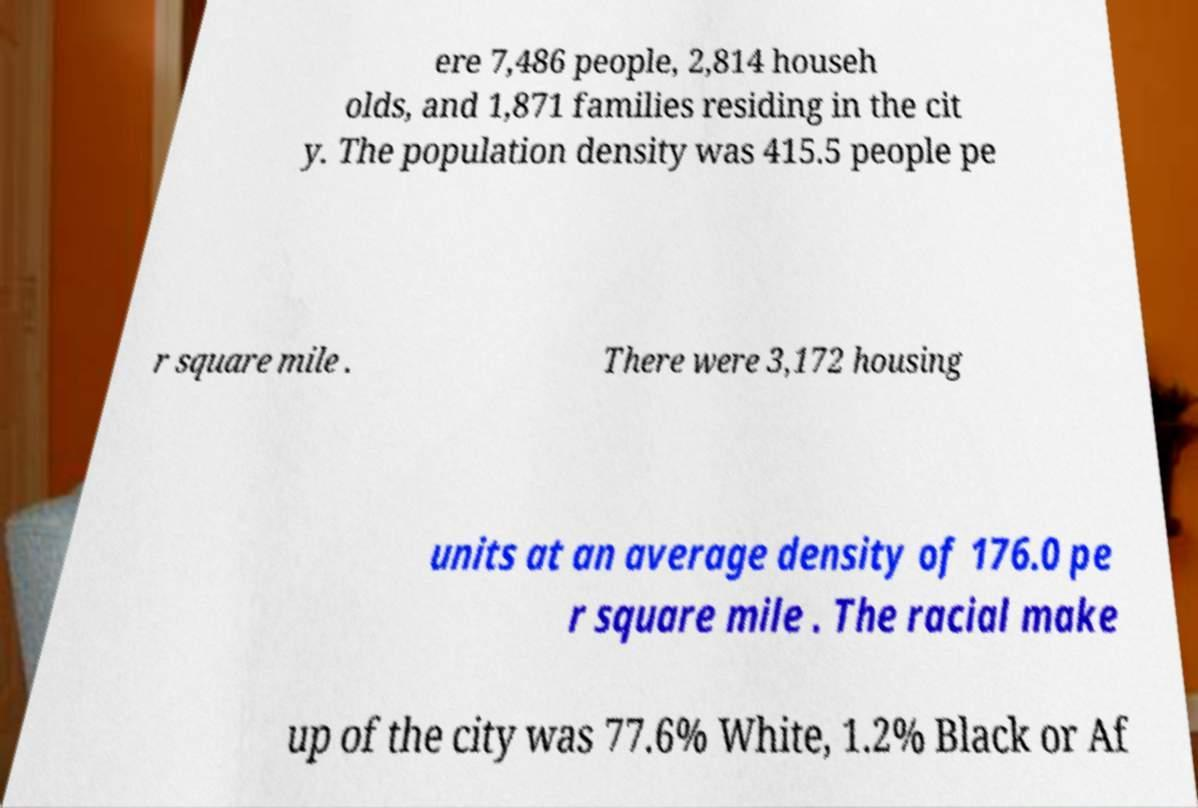Could you assist in decoding the text presented in this image and type it out clearly? ere 7,486 people, 2,814 househ olds, and 1,871 families residing in the cit y. The population density was 415.5 people pe r square mile . There were 3,172 housing units at an average density of 176.0 pe r square mile . The racial make up of the city was 77.6% White, 1.2% Black or Af 